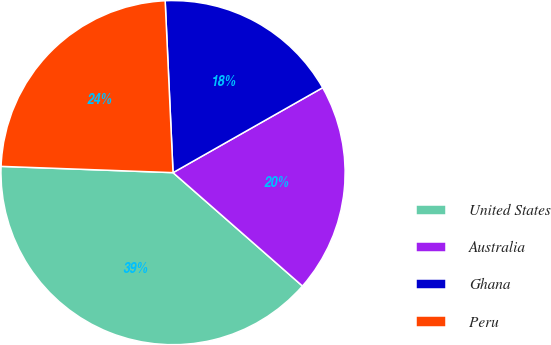<chart> <loc_0><loc_0><loc_500><loc_500><pie_chart><fcel>United States<fcel>Australia<fcel>Ghana<fcel>Peru<nl><fcel>39.13%<fcel>19.67%<fcel>17.51%<fcel>23.69%<nl></chart> 